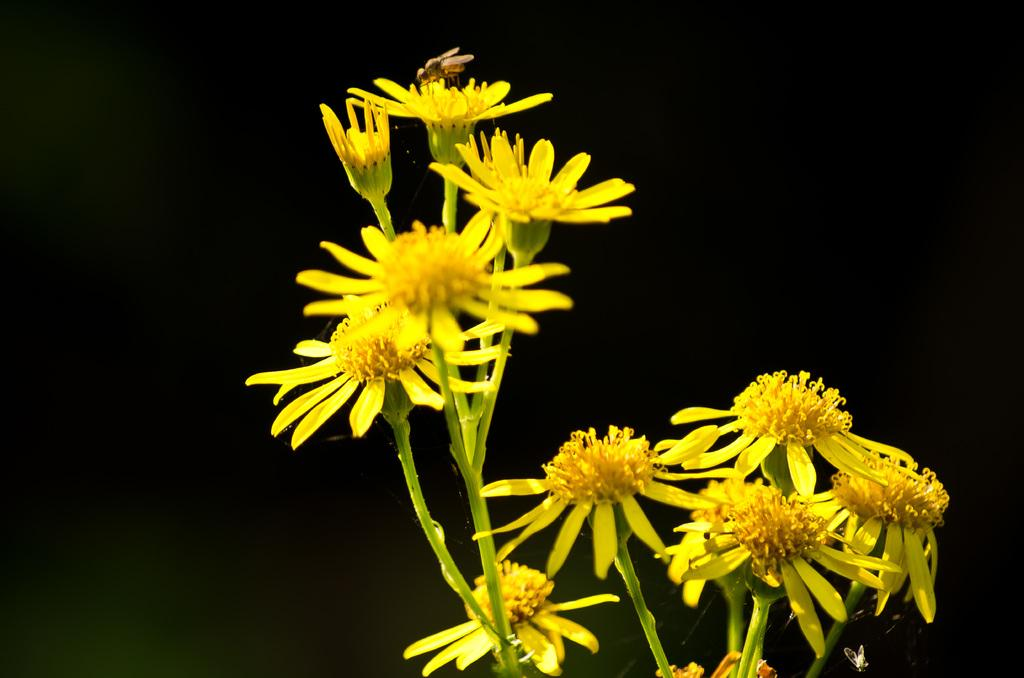What is located in the center of the image? There are flowers in the center of the image. What other living organism can be seen in the image? There is a honey bee in the image. What type of car is parked next to the flowers in the image? There is no car present in the image; it only features flowers and a honey bee. 